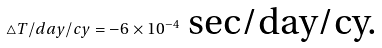<formula> <loc_0><loc_0><loc_500><loc_500>\triangle T / d a y / c y = - 6 \times 1 0 ^ { - 4 } \text { sec/day/cy.}</formula> 